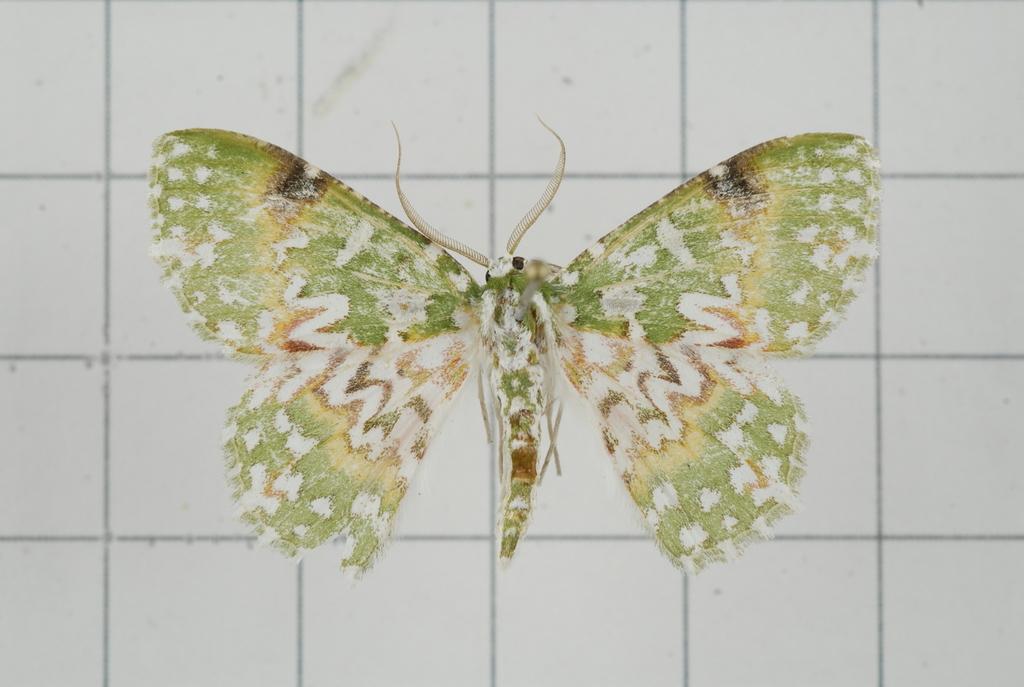Describe this image in one or two sentences. In this image there is a wall and we can see a wall painting on it. 